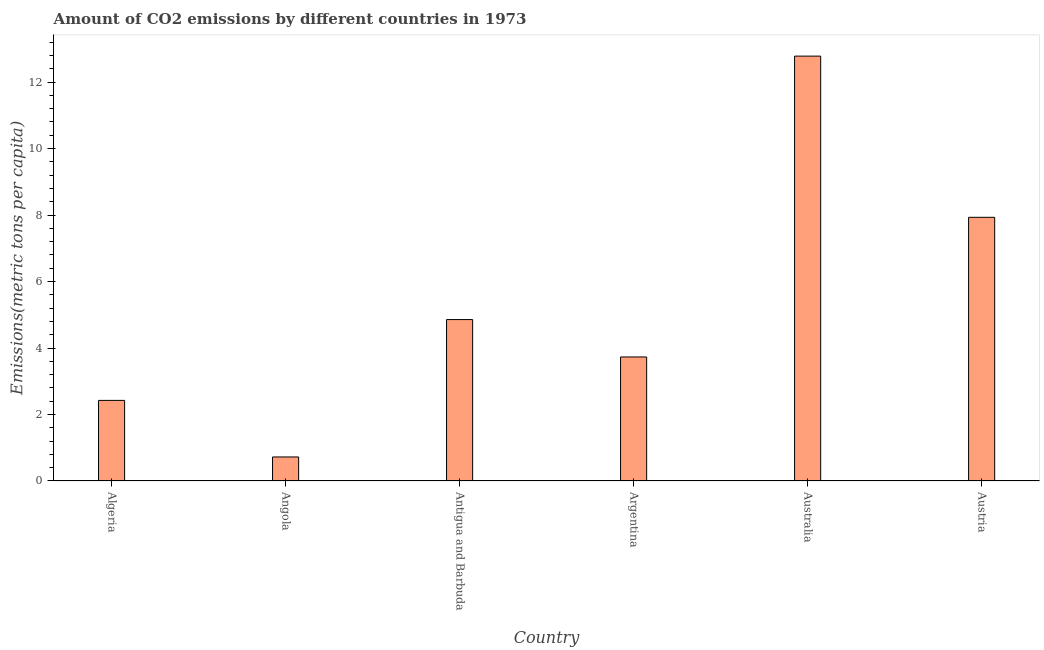What is the title of the graph?
Offer a very short reply. Amount of CO2 emissions by different countries in 1973. What is the label or title of the Y-axis?
Provide a short and direct response. Emissions(metric tons per capita). What is the amount of co2 emissions in Australia?
Offer a terse response. 12.78. Across all countries, what is the maximum amount of co2 emissions?
Your answer should be compact. 12.78. Across all countries, what is the minimum amount of co2 emissions?
Offer a very short reply. 0.72. In which country was the amount of co2 emissions maximum?
Your answer should be very brief. Australia. In which country was the amount of co2 emissions minimum?
Make the answer very short. Angola. What is the sum of the amount of co2 emissions?
Offer a very short reply. 32.44. What is the difference between the amount of co2 emissions in Argentina and Australia?
Ensure brevity in your answer.  -9.05. What is the average amount of co2 emissions per country?
Your response must be concise. 5.41. What is the median amount of co2 emissions?
Your answer should be compact. 4.29. What is the ratio of the amount of co2 emissions in Antigua and Barbuda to that in Argentina?
Make the answer very short. 1.3. Is the amount of co2 emissions in Algeria less than that in Antigua and Barbuda?
Your answer should be compact. Yes. Is the difference between the amount of co2 emissions in Angola and Australia greater than the difference between any two countries?
Give a very brief answer. Yes. What is the difference between the highest and the second highest amount of co2 emissions?
Ensure brevity in your answer.  4.85. Is the sum of the amount of co2 emissions in Argentina and Austria greater than the maximum amount of co2 emissions across all countries?
Make the answer very short. No. What is the difference between the highest and the lowest amount of co2 emissions?
Give a very brief answer. 12.06. In how many countries, is the amount of co2 emissions greater than the average amount of co2 emissions taken over all countries?
Keep it short and to the point. 2. How many countries are there in the graph?
Offer a very short reply. 6. What is the difference between two consecutive major ticks on the Y-axis?
Your response must be concise. 2. Are the values on the major ticks of Y-axis written in scientific E-notation?
Your response must be concise. No. What is the Emissions(metric tons per capita) in Algeria?
Give a very brief answer. 2.42. What is the Emissions(metric tons per capita) of Angola?
Provide a succinct answer. 0.72. What is the Emissions(metric tons per capita) of Antigua and Barbuda?
Give a very brief answer. 4.86. What is the Emissions(metric tons per capita) in Argentina?
Your answer should be very brief. 3.73. What is the Emissions(metric tons per capita) of Australia?
Keep it short and to the point. 12.78. What is the Emissions(metric tons per capita) of Austria?
Offer a terse response. 7.93. What is the difference between the Emissions(metric tons per capita) in Algeria and Angola?
Your response must be concise. 1.7. What is the difference between the Emissions(metric tons per capita) in Algeria and Antigua and Barbuda?
Provide a short and direct response. -2.43. What is the difference between the Emissions(metric tons per capita) in Algeria and Argentina?
Your answer should be very brief. -1.31. What is the difference between the Emissions(metric tons per capita) in Algeria and Australia?
Keep it short and to the point. -10.36. What is the difference between the Emissions(metric tons per capita) in Algeria and Austria?
Provide a succinct answer. -5.51. What is the difference between the Emissions(metric tons per capita) in Angola and Antigua and Barbuda?
Provide a succinct answer. -4.13. What is the difference between the Emissions(metric tons per capita) in Angola and Argentina?
Make the answer very short. -3.01. What is the difference between the Emissions(metric tons per capita) in Angola and Australia?
Make the answer very short. -12.06. What is the difference between the Emissions(metric tons per capita) in Angola and Austria?
Your response must be concise. -7.21. What is the difference between the Emissions(metric tons per capita) in Antigua and Barbuda and Argentina?
Your response must be concise. 1.12. What is the difference between the Emissions(metric tons per capita) in Antigua and Barbuda and Australia?
Offer a terse response. -7.92. What is the difference between the Emissions(metric tons per capita) in Antigua and Barbuda and Austria?
Provide a succinct answer. -3.08. What is the difference between the Emissions(metric tons per capita) in Argentina and Australia?
Your answer should be very brief. -9.05. What is the difference between the Emissions(metric tons per capita) in Argentina and Austria?
Offer a very short reply. -4.2. What is the difference between the Emissions(metric tons per capita) in Australia and Austria?
Offer a terse response. 4.85. What is the ratio of the Emissions(metric tons per capita) in Algeria to that in Angola?
Give a very brief answer. 3.35. What is the ratio of the Emissions(metric tons per capita) in Algeria to that in Antigua and Barbuda?
Give a very brief answer. 0.5. What is the ratio of the Emissions(metric tons per capita) in Algeria to that in Argentina?
Offer a terse response. 0.65. What is the ratio of the Emissions(metric tons per capita) in Algeria to that in Australia?
Provide a succinct answer. 0.19. What is the ratio of the Emissions(metric tons per capita) in Algeria to that in Austria?
Ensure brevity in your answer.  0.31. What is the ratio of the Emissions(metric tons per capita) in Angola to that in Antigua and Barbuda?
Keep it short and to the point. 0.15. What is the ratio of the Emissions(metric tons per capita) in Angola to that in Argentina?
Your response must be concise. 0.19. What is the ratio of the Emissions(metric tons per capita) in Angola to that in Australia?
Ensure brevity in your answer.  0.06. What is the ratio of the Emissions(metric tons per capita) in Angola to that in Austria?
Keep it short and to the point. 0.09. What is the ratio of the Emissions(metric tons per capita) in Antigua and Barbuda to that in Argentina?
Offer a terse response. 1.3. What is the ratio of the Emissions(metric tons per capita) in Antigua and Barbuda to that in Australia?
Your answer should be very brief. 0.38. What is the ratio of the Emissions(metric tons per capita) in Antigua and Barbuda to that in Austria?
Your answer should be compact. 0.61. What is the ratio of the Emissions(metric tons per capita) in Argentina to that in Australia?
Give a very brief answer. 0.29. What is the ratio of the Emissions(metric tons per capita) in Argentina to that in Austria?
Keep it short and to the point. 0.47. What is the ratio of the Emissions(metric tons per capita) in Australia to that in Austria?
Ensure brevity in your answer.  1.61. 